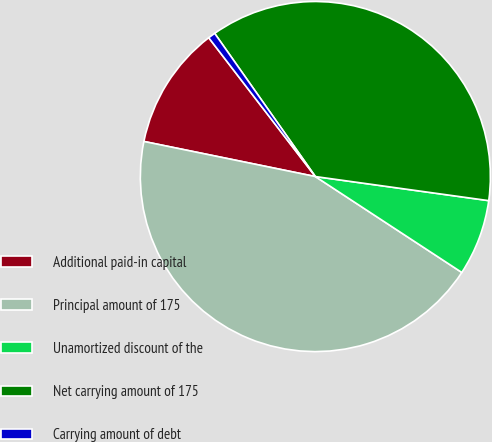<chart> <loc_0><loc_0><loc_500><loc_500><pie_chart><fcel>Additional paid-in capital<fcel>Principal amount of 175<fcel>Unamortized discount of the<fcel>Net carrying amount of 175<fcel>Carrying amount of debt<nl><fcel>11.36%<fcel>43.98%<fcel>7.03%<fcel>36.95%<fcel>0.67%<nl></chart> 